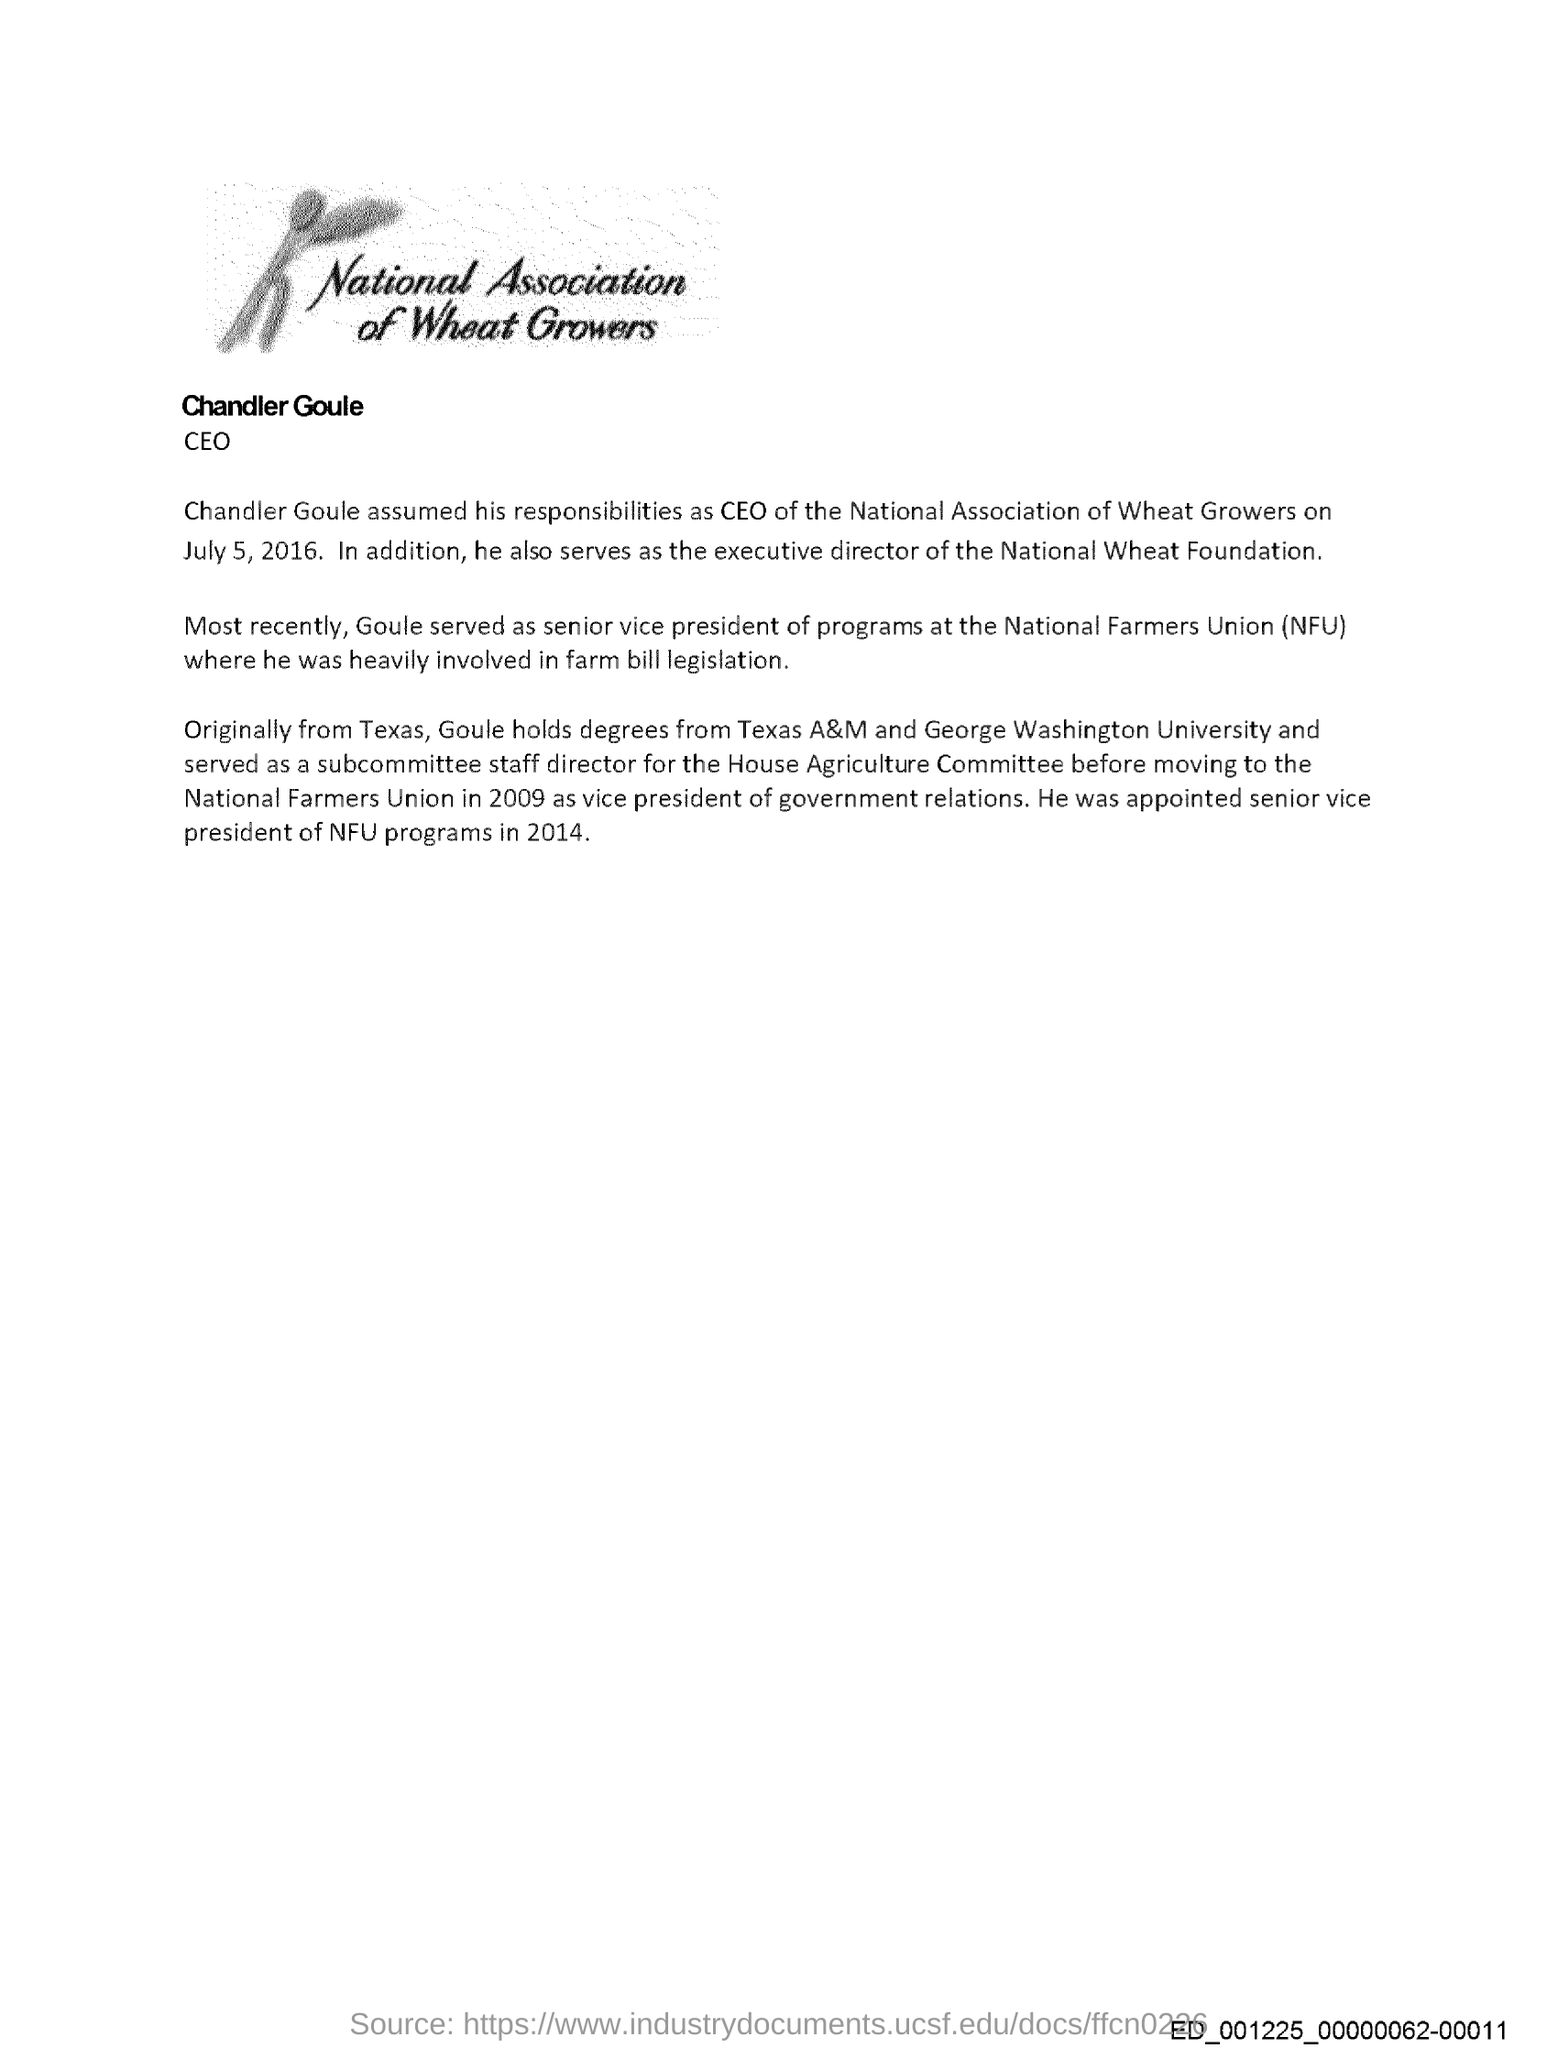Give some essential details in this illustration. Chandler Goule served as the Executive Director of the National Wheat Foundation. Goule holds a degree from both Texas A&M University and George Washington University. Goule previously worked as the senior vice president of programs at the National Farmers Union. Chandler Goule assumed his responsibilities as CEO on July 5, 2016. The National Farmers Union is a group that supports the interests of farmers and promotes their well-being. 